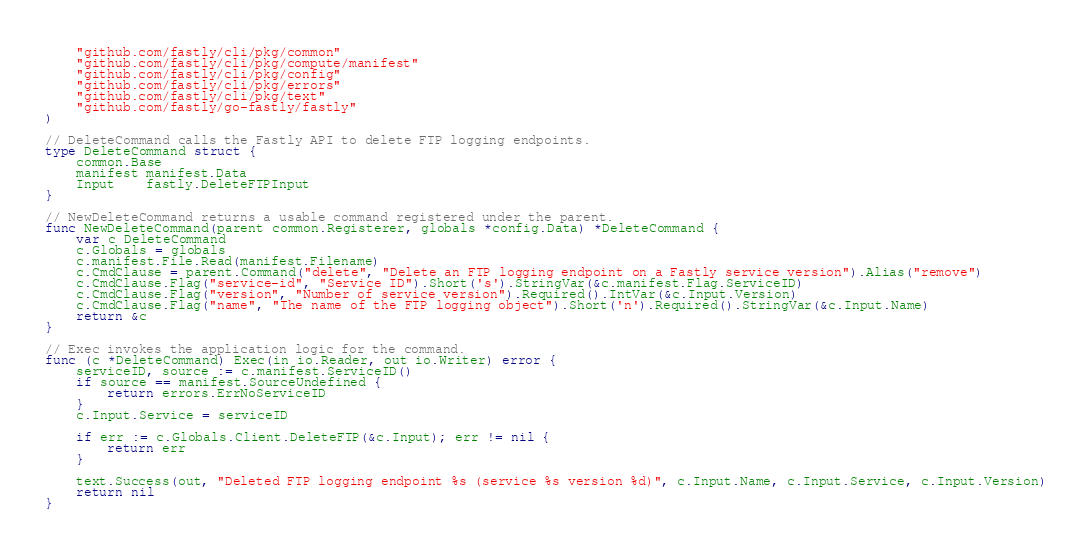<code> <loc_0><loc_0><loc_500><loc_500><_Go_>
	"github.com/fastly/cli/pkg/common"
	"github.com/fastly/cli/pkg/compute/manifest"
	"github.com/fastly/cli/pkg/config"
	"github.com/fastly/cli/pkg/errors"
	"github.com/fastly/cli/pkg/text"
	"github.com/fastly/go-fastly/fastly"
)

// DeleteCommand calls the Fastly API to delete FTP logging endpoints.
type DeleteCommand struct {
	common.Base
	manifest manifest.Data
	Input    fastly.DeleteFTPInput
}

// NewDeleteCommand returns a usable command registered under the parent.
func NewDeleteCommand(parent common.Registerer, globals *config.Data) *DeleteCommand {
	var c DeleteCommand
	c.Globals = globals
	c.manifest.File.Read(manifest.Filename)
	c.CmdClause = parent.Command("delete", "Delete an FTP logging endpoint on a Fastly service version").Alias("remove")
	c.CmdClause.Flag("service-id", "Service ID").Short('s').StringVar(&c.manifest.Flag.ServiceID)
	c.CmdClause.Flag("version", "Number of service version").Required().IntVar(&c.Input.Version)
	c.CmdClause.Flag("name", "The name of the FTP logging object").Short('n').Required().StringVar(&c.Input.Name)
	return &c
}

// Exec invokes the application logic for the command.
func (c *DeleteCommand) Exec(in io.Reader, out io.Writer) error {
	serviceID, source := c.manifest.ServiceID()
	if source == manifest.SourceUndefined {
		return errors.ErrNoServiceID
	}
	c.Input.Service = serviceID

	if err := c.Globals.Client.DeleteFTP(&c.Input); err != nil {
		return err
	}

	text.Success(out, "Deleted FTP logging endpoint %s (service %s version %d)", c.Input.Name, c.Input.Service, c.Input.Version)
	return nil
}
</code> 